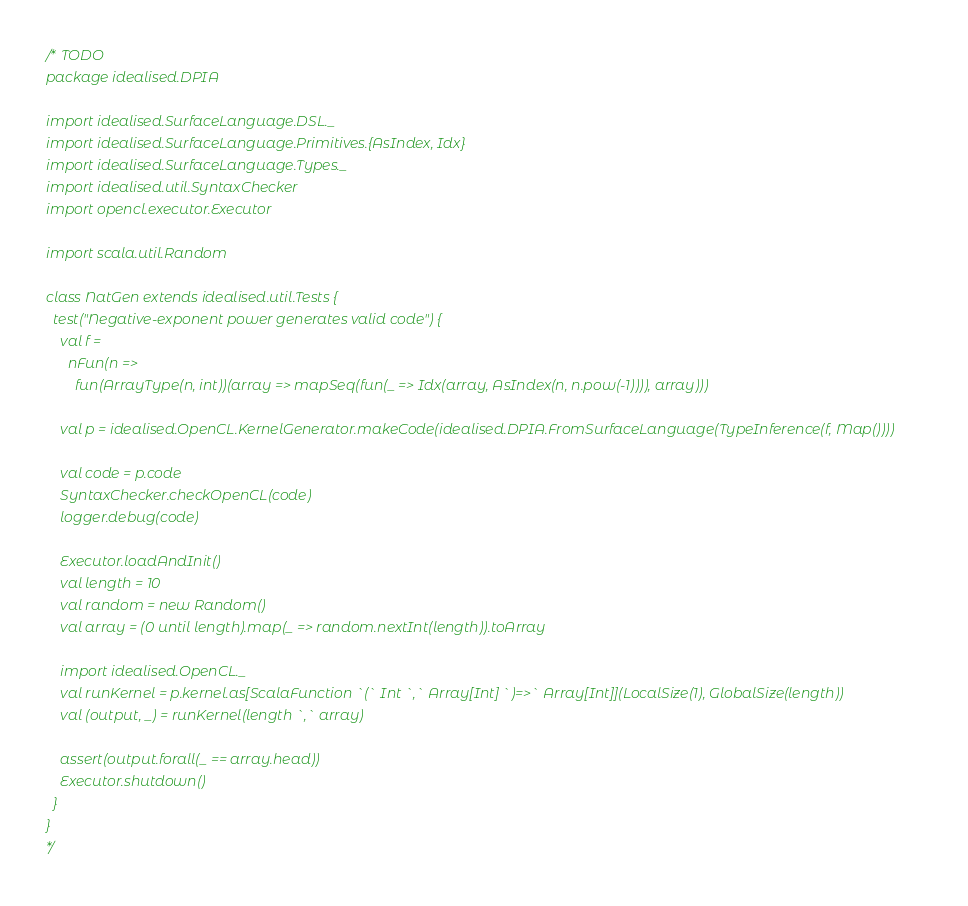<code> <loc_0><loc_0><loc_500><loc_500><_Scala_>/* TODO
package idealised.DPIA

import idealised.SurfaceLanguage.DSL._
import idealised.SurfaceLanguage.Primitives.{AsIndex, Idx}
import idealised.SurfaceLanguage.Types._
import idealised.util.SyntaxChecker
import opencl.executor.Executor

import scala.util.Random

class NatGen extends idealised.util.Tests {
  test("Negative-exponent power generates valid code") {
    val f =
      nFun(n =>
        fun(ArrayType(n, int))(array => mapSeq(fun(_ => Idx(array, AsIndex(n, n.pow(-1)))), array)))

    val p = idealised.OpenCL.KernelGenerator.makeCode(idealised.DPIA.FromSurfaceLanguage(TypeInference(f, Map())))

    val code = p.code
    SyntaxChecker.checkOpenCL(code)
    logger.debug(code)

    Executor.loadAndInit()
    val length = 10
    val random = new Random()
    val array = (0 until length).map(_ => random.nextInt(length)).toArray

    import idealised.OpenCL._
    val runKernel = p.kernel.as[ScalaFunction `(` Int `,` Array[Int] `)=>` Array[Int]](LocalSize(1), GlobalSize(length))
    val (output, _) = runKernel(length `,` array)

    assert(output.forall(_ == array.head))
    Executor.shutdown()
  }
}
*/</code> 